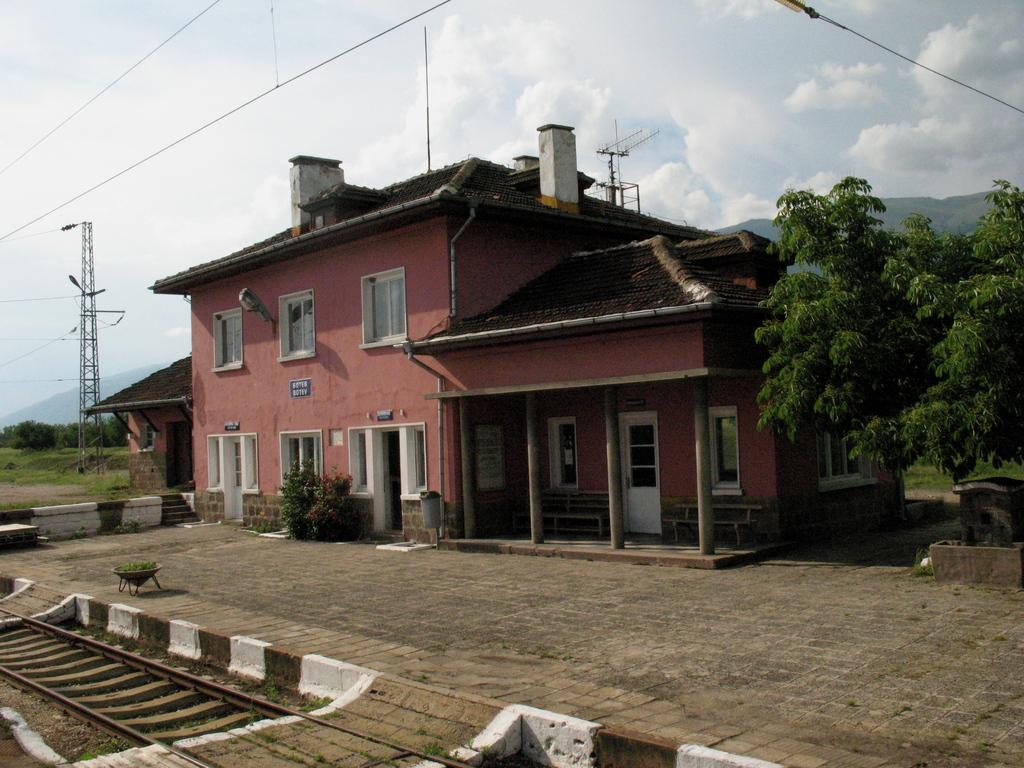What type of structure is visible in the image? There is a building in the image. What is located near the building? There is a railway track in the image. What is on top of the building? There is an antenna on the building. What type of vegetation can be seen in the image? There are plants and many trees in the image. What type of geographical feature is visible in the image? There are hills in the image. What type of nut is used to secure the antenna to the building? There is no mention of nuts or any specific fastening method for the antenna in the image. What hobbies do the trees in the image enjoy? Trees do not have hobbies, as they are inanimate objects. 